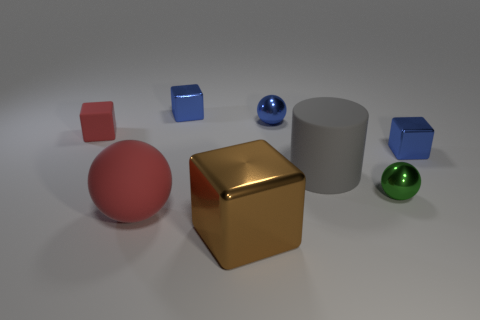What is the size of the red rubber object in front of the red rubber thing behind the large matte ball?
Keep it short and to the point. Large. What is the shape of the brown shiny object?
Give a very brief answer. Cube. There is a red object that is behind the large cylinder; what material is it?
Make the answer very short. Rubber. What color is the small block that is to the right of the large object in front of the big matte thing that is on the left side of the brown block?
Your answer should be compact. Blue. There is a cylinder that is the same size as the brown metal cube; what is its color?
Offer a terse response. Gray. What number of matte objects are cubes or red blocks?
Offer a very short reply. 1. What is the color of the block that is made of the same material as the large red sphere?
Offer a terse response. Red. What is the material of the red thing that is in front of the tiny blue block that is right of the small green shiny sphere?
Provide a succinct answer. Rubber. What number of objects are small things left of the large red thing or balls that are to the left of the big gray rubber thing?
Provide a short and direct response. 3. What is the size of the blue shiny object in front of the red rubber object left of the red object in front of the tiny green ball?
Offer a terse response. Small. 